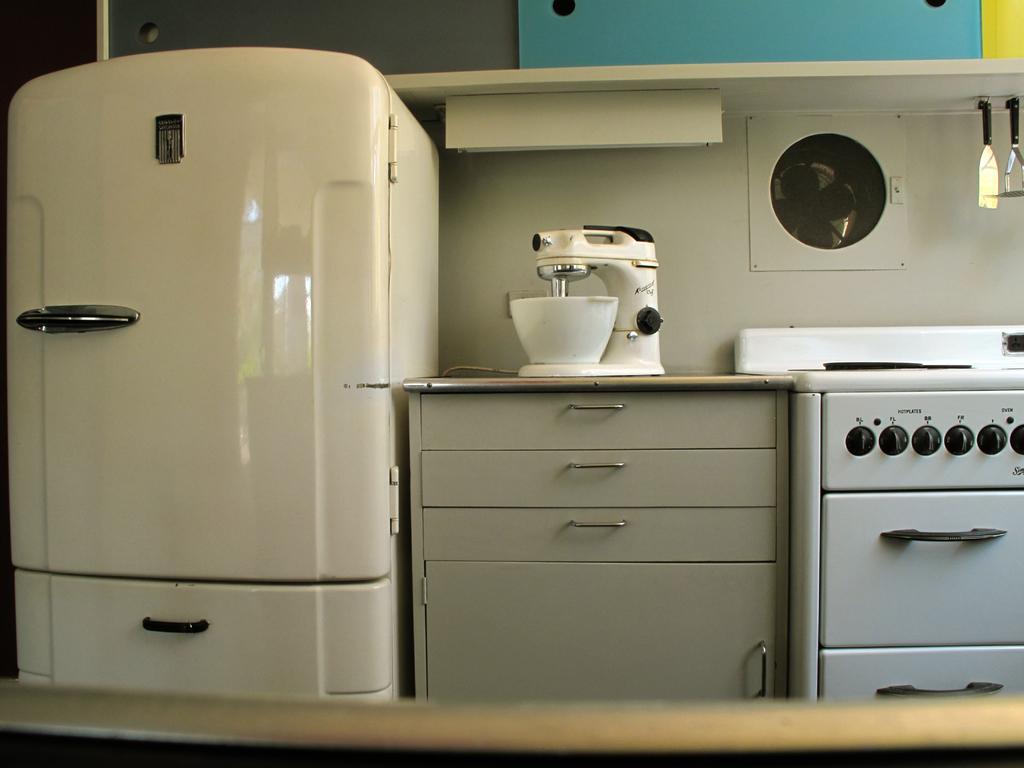Can you describe this image briefly? This picture is an inside view of a room. In this picture we can see the containers, cupboards, object, fan, wall, shelf and text. 